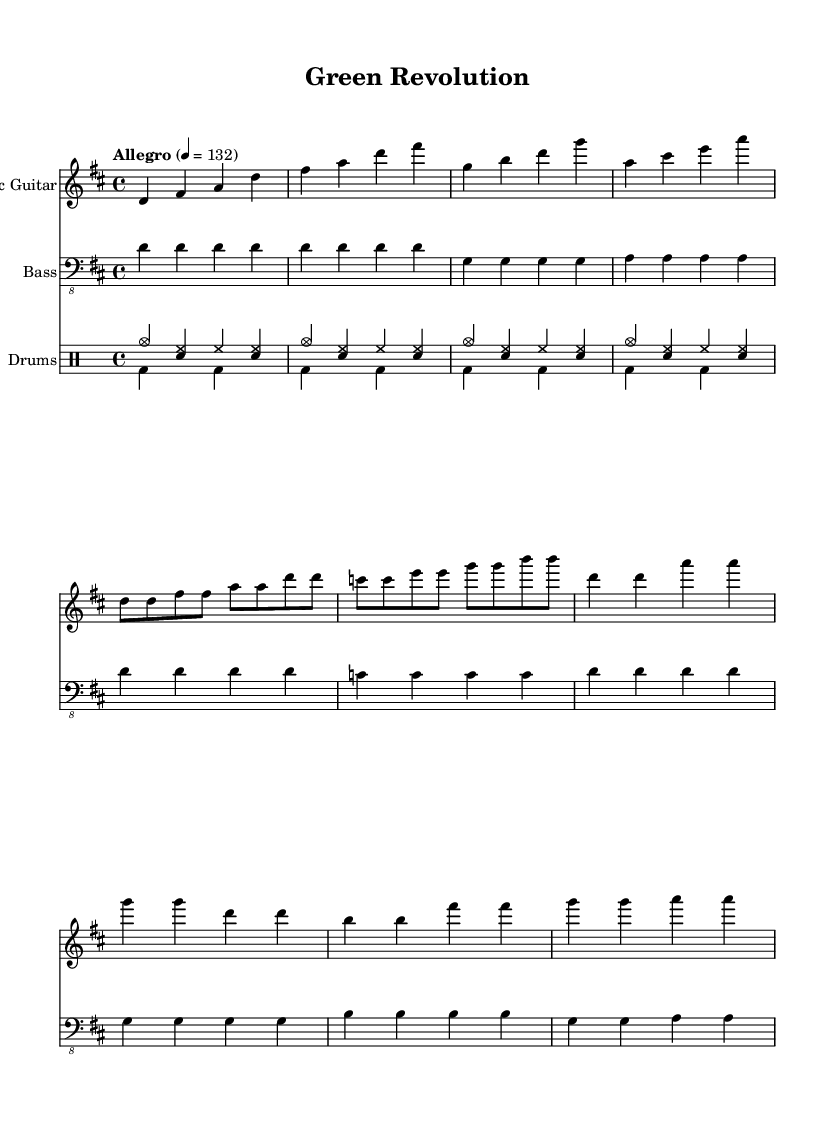What is the key signature of this music? The key signature is indicated at the beginning of the staff, and it shows two sharps, which correspond to the notes F# and C#. This indicates that the piece is in D major.
Answer: D major What is the time signature of this music? The time signature is found at the beginning of the score, indicating how many beats are in each measure and what note value is considered one beat. Here it shows 4/4, meaning there are four beats per measure and the quarter note gets one beat.
Answer: 4/4 What is the tempo marking of this piece? The tempo marking is located before the staff and indicates the speed of the piece. In this case, it specifies "Allegro" at a metronome marking of 132, which denotes a lively and fast pace.
Answer: 132 What is the primary genre of this composition? The style and instrumentation suggest that this piece belongs to the energetic indie rock genre, which is characterized by upbeat rhythms and guitar-driven melodies.
Answer: Indie rock How many sections does the music have, and can you name them? By analyzing the structure outlined in the music, we can identify three distinct sections: the Intro, Verse, and Chorus. This can be determined by the different patterns and changes in the notes used in these parts.
Answer: Intro, Verse, Chorus What instruments are featured in this score? The score lists three main parts, which are typically associated with a rock band setup: Electric Guitar, Bass, and Drums. This can be checked in the staff titles at the beginning of each section in the score.
Answer: Electric Guitar, Bass, Drums How is the rhythm in the drums part characterized? The drums part features a basic rock beat pattern repeated throughout, indicated by the notation that shows hi-hats, snares, and bass drums, which create a driving rhythm typical in rock music.
Answer: Basic rock beat 